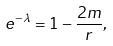Convert formula to latex. <formula><loc_0><loc_0><loc_500><loc_500>e ^ { - \lambda } = 1 - \frac { 2 m } { r } ,</formula> 